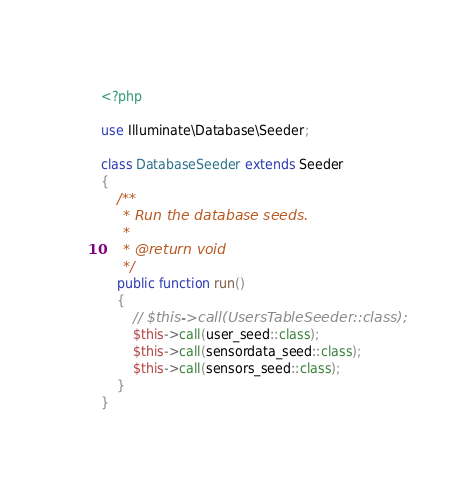Convert code to text. <code><loc_0><loc_0><loc_500><loc_500><_PHP_><?php

use Illuminate\Database\Seeder;

class DatabaseSeeder extends Seeder
{
    /**
     * Run the database seeds.
     *
     * @return void
     */
    public function run()
    {
        // $this->call(UsersTableSeeder::class);
        $this->call(user_seed::class);
        $this->call(sensordata_seed::class);
        $this->call(sensors_seed::class);
    }
}
</code> 